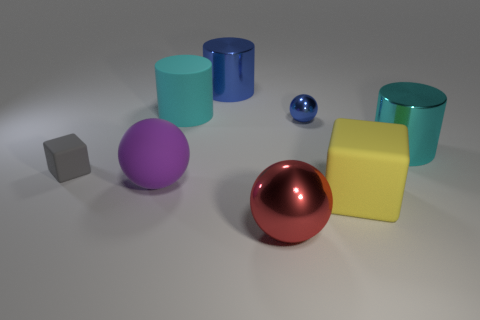Add 1 gray rubber things. How many objects exist? 9 Subtract all blocks. How many objects are left? 6 Add 1 large metallic objects. How many large metallic objects are left? 4 Add 1 yellow blocks. How many yellow blocks exist? 2 Subtract 1 yellow cubes. How many objects are left? 7 Subtract all small gray cubes. Subtract all large objects. How many objects are left? 1 